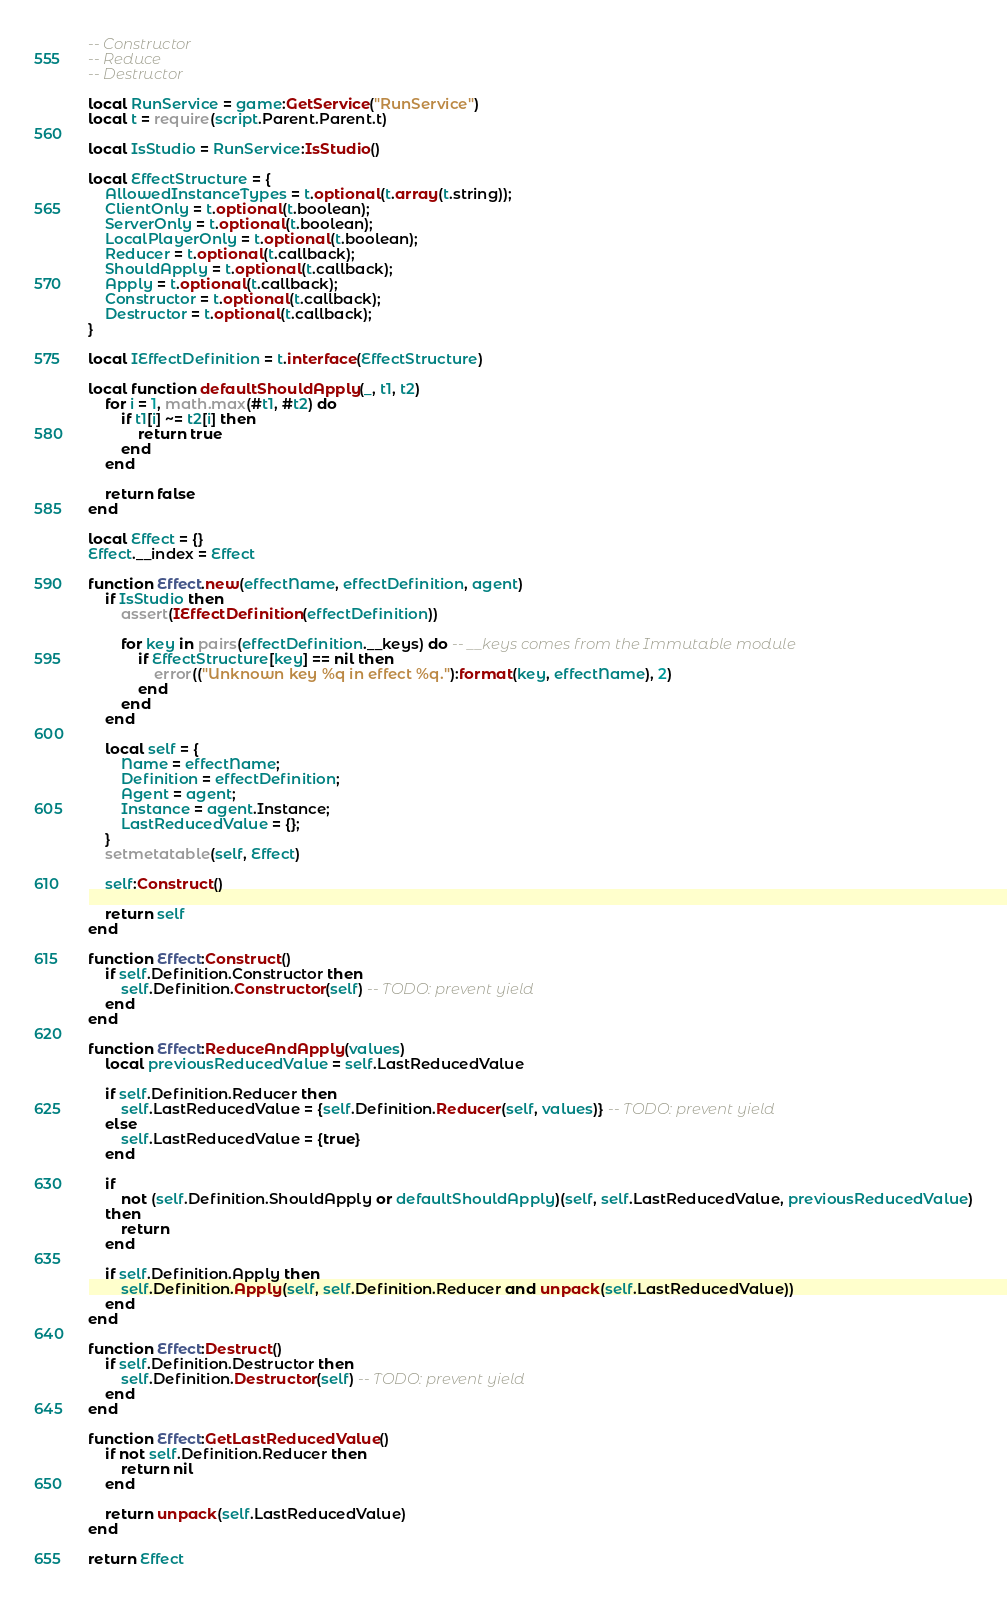<code> <loc_0><loc_0><loc_500><loc_500><_Lua_>-- Constructor
-- Reduce
-- Destructor

local RunService = game:GetService("RunService")
local t = require(script.Parent.Parent.t)

local IsStudio = RunService:IsStudio()

local EffectStructure = {
	AllowedInstanceTypes = t.optional(t.array(t.string));
	ClientOnly = t.optional(t.boolean);
	ServerOnly = t.optional(t.boolean);
	LocalPlayerOnly = t.optional(t.boolean);
	Reducer = t.optional(t.callback);
	ShouldApply = t.optional(t.callback);
	Apply = t.optional(t.callback);
	Constructor = t.optional(t.callback);
	Destructor = t.optional(t.callback);
}

local IEffectDefinition = t.interface(EffectStructure)

local function defaultShouldApply(_, t1, t2)
	for i = 1, math.max(#t1, #t2) do
		if t1[i] ~= t2[i] then
			return true
		end
	end

	return false
end

local Effect = {}
Effect.__index = Effect

function Effect.new(effectName, effectDefinition, agent)
	if IsStudio then
		assert(IEffectDefinition(effectDefinition))

		for key in pairs(effectDefinition.__keys) do -- __keys comes from the Immutable module
			if EffectStructure[key] == nil then
				error(("Unknown key %q in effect %q."):format(key, effectName), 2)
			end
		end
	end

	local self = {
		Name = effectName;
		Definition = effectDefinition;
		Agent = agent;
		Instance = agent.Instance;
		LastReducedValue = {};
	}
	setmetatable(self, Effect)

	self:Construct()

	return self
end

function Effect:Construct()
	if self.Definition.Constructor then
		self.Definition.Constructor(self) -- TODO: prevent yield
	end
end

function Effect:ReduceAndApply(values)
	local previousReducedValue = self.LastReducedValue

	if self.Definition.Reducer then
		self.LastReducedValue = {self.Definition.Reducer(self, values)} -- TODO: prevent yield
	else
		self.LastReducedValue = {true}
	end

	if
		not (self.Definition.ShouldApply or defaultShouldApply)(self, self.LastReducedValue, previousReducedValue)
	then
		return
	end

	if self.Definition.Apply then
		self.Definition.Apply(self, self.Definition.Reducer and unpack(self.LastReducedValue))
	end
end

function Effect:Destruct()
	if self.Definition.Destructor then
		self.Definition.Destructor(self) -- TODO: prevent yield
	end
end

function Effect:GetLastReducedValue()
	if not self.Definition.Reducer then
		return nil
	end

	return unpack(self.LastReducedValue)
end

return Effect</code> 